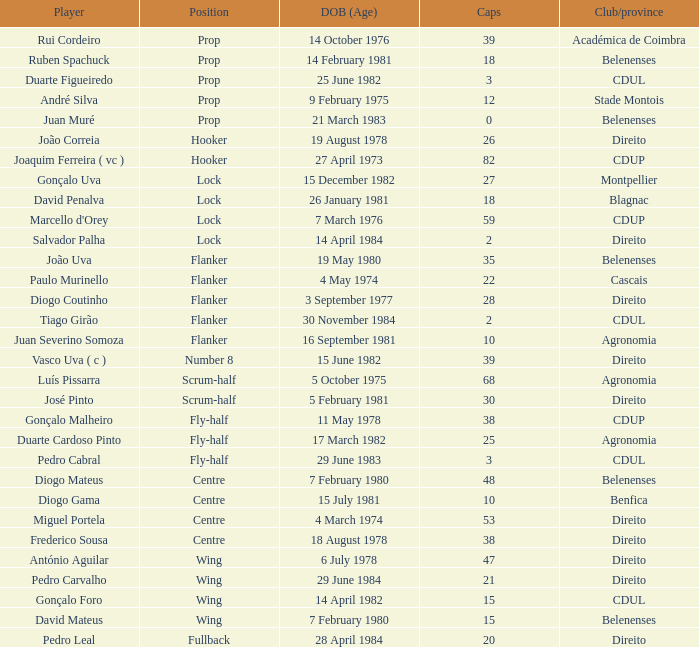How many caps have a Position of prop, and a Player of rui cordeiro? 1.0. 